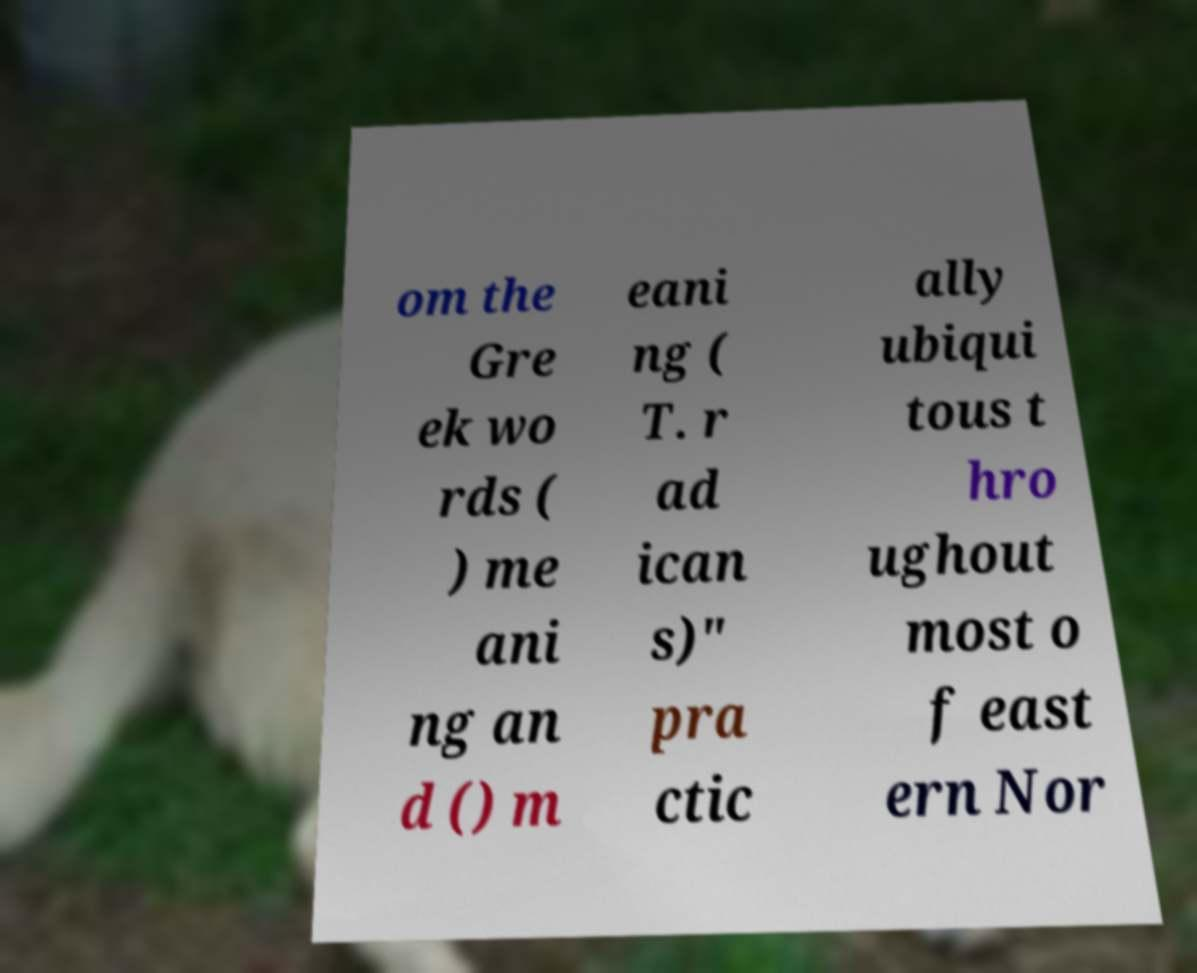Could you assist in decoding the text presented in this image and type it out clearly? om the Gre ek wo rds ( ) me ani ng an d () m eani ng ( T. r ad ican s)" pra ctic ally ubiqui tous t hro ughout most o f east ern Nor 